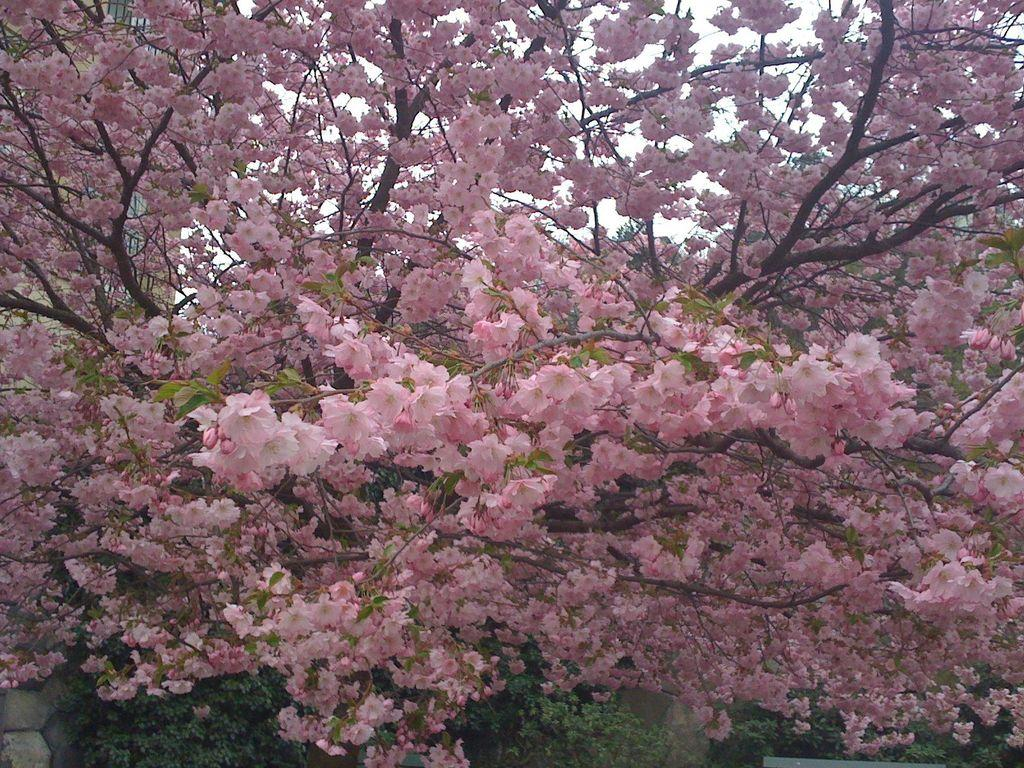What is present in the image? There is a tree in the image. What can be observed about the tree? The tree has pink flowers on top. How many pigs are wearing coats and boots in the image? There are no pigs, coats, or boots present in the image; it features a tree with pink flowers. 